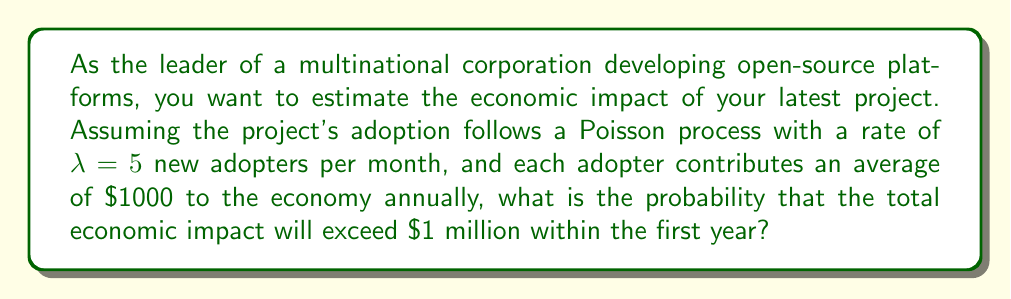Can you answer this question? To solve this problem, we need to follow these steps:

1. Determine the number of adopters needed to exceed $1 million in economic impact.
2. Model the adoption process using a Poisson distribution.
3. Calculate the probability of reaching or exceeding the required number of adopters.

Step 1: Determining the number of adopters
Each adopter contributes $\$1000$ annually. To exceed $\$1$ million, we need:
$$ \text{Number of adopters} > \frac{\$1,000,000}{\$1,000} = 1000 $$

Step 2: Modeling the adoption process
The adoption follows a Poisson process with rate $\lambda = 5$ per month. For a full year, the rate is:
$$ \lambda_{\text{year}} = 5 \times 12 = 60 $$

The number of adopters in a year follows a Poisson distribution with mean $\lambda_{\text{year}} = 60$.

Step 3: Calculating the probability
We need to find $P(X > 1000)$, where $X$ is the number of adopters in a year. This is equivalent to $1 - P(X \leq 1000)$.

Using the cumulative distribution function of the Poisson distribution:

$$ P(X \leq 1000) = e^{-60} \sum_{k=0}^{1000} \frac{60^k}{k!} $$

This sum is computationally intensive, so we can use the normal approximation to the Poisson distribution for large $\lambda$:

$$ X \sim N(\mu = 60, \sigma^2 = 60) $$

Standardizing:
$$ z = \frac{1000.5 - 60}{\sqrt{60}} \approx 121.32 $$

(We use 1000.5 for continuity correction)

Using the standard normal distribution table or a calculator:

$$ P(X \leq 1000) \approx P(Z \leq 121.32) \approx 1 $$

Therefore:
$$ P(X > 1000) \approx 1 - P(X \leq 1000) \approx 0 $$
Answer: The probability that the total economic impact will exceed $1 million within the first year is approximately 0. 